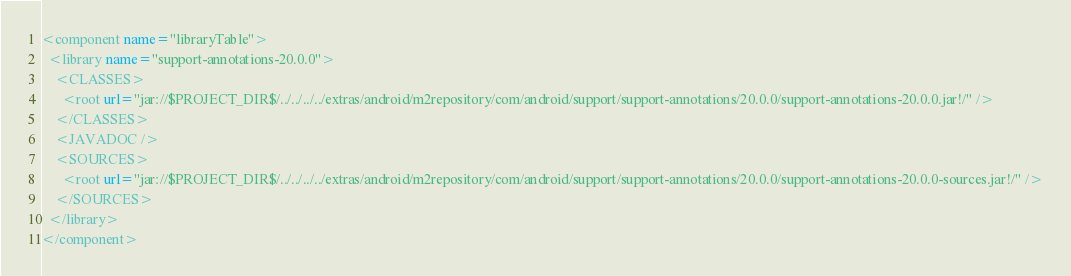Convert code to text. <code><loc_0><loc_0><loc_500><loc_500><_XML_><component name="libraryTable">
  <library name="support-annotations-20.0.0">
    <CLASSES>
      <root url="jar://$PROJECT_DIR$/../../../../extras/android/m2repository/com/android/support/support-annotations/20.0.0/support-annotations-20.0.0.jar!/" />
    </CLASSES>
    <JAVADOC />
    <SOURCES>
      <root url="jar://$PROJECT_DIR$/../../../../extras/android/m2repository/com/android/support/support-annotations/20.0.0/support-annotations-20.0.0-sources.jar!/" />
    </SOURCES>
  </library>
</component></code> 